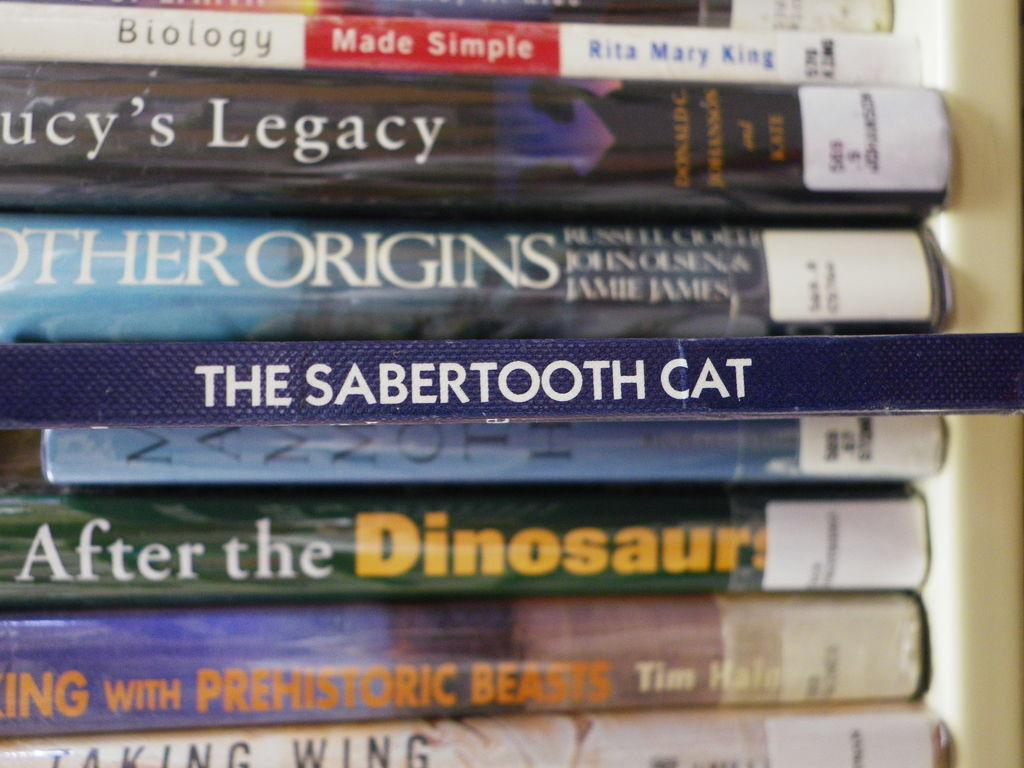<image>
Describe the image concisely. Amongst a group of books seen horizontally one titled the sabertoothcat is highlighted and stands out. 